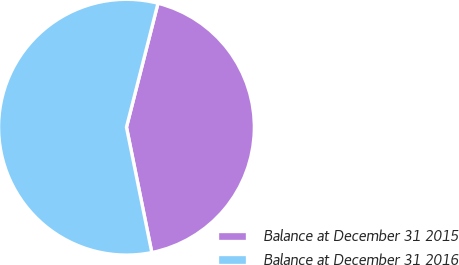Convert chart. <chart><loc_0><loc_0><loc_500><loc_500><pie_chart><fcel>Balance at December 31 2015<fcel>Balance at December 31 2016<nl><fcel>42.86%<fcel>57.14%<nl></chart> 